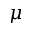<formula> <loc_0><loc_0><loc_500><loc_500>\mu</formula> 